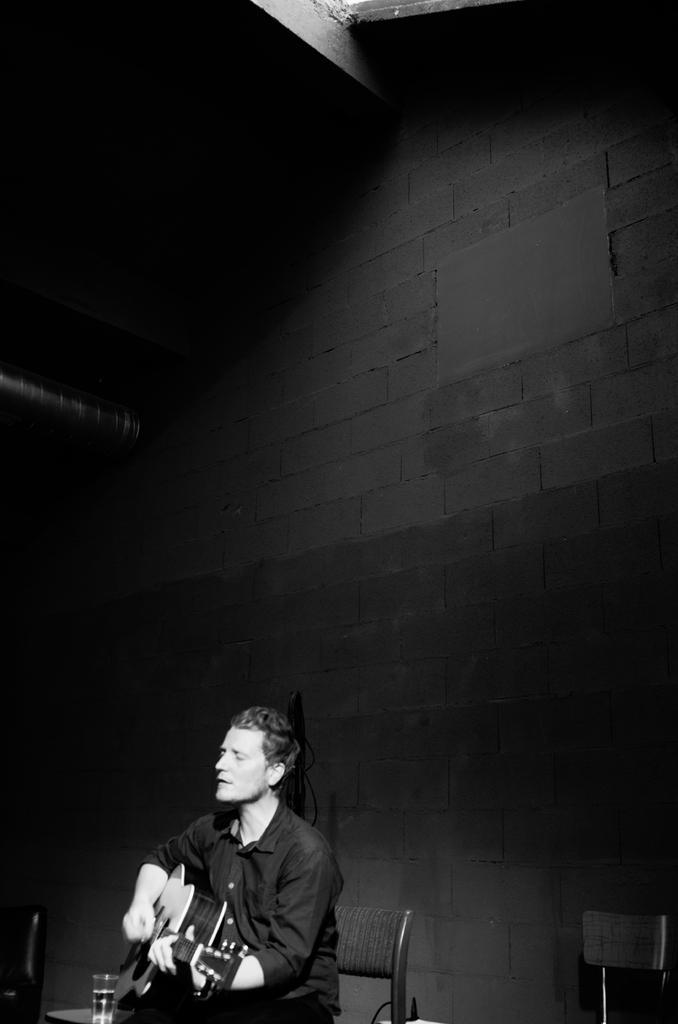Describe this image in one or two sentences. In the middle a man is sitting on the chair and also playing the guitar there is a water bottle on the table. 